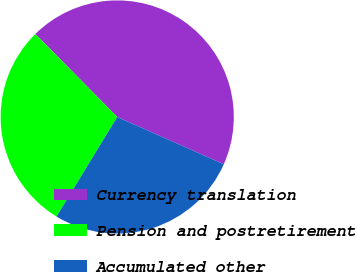Convert chart to OTSL. <chart><loc_0><loc_0><loc_500><loc_500><pie_chart><fcel>Currency translation<fcel>Pension and postretirement<fcel>Accumulated other<nl><fcel>44.04%<fcel>28.89%<fcel>27.07%<nl></chart> 